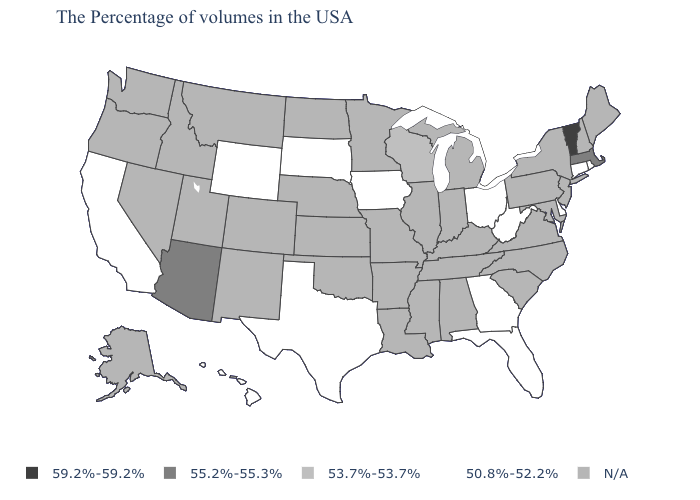What is the value of Texas?
Answer briefly. 50.8%-52.2%. Among the states that border Kentucky , which have the highest value?
Give a very brief answer. West Virginia, Ohio. What is the value of Massachusetts?
Be succinct. 55.2%-55.3%. Name the states that have a value in the range 55.2%-55.3%?
Answer briefly. Massachusetts, Arizona. Name the states that have a value in the range 50.8%-52.2%?
Answer briefly. Rhode Island, Connecticut, Delaware, West Virginia, Ohio, Florida, Georgia, Iowa, Texas, South Dakota, Wyoming, California, Hawaii. What is the value of Kansas?
Be succinct. N/A. What is the highest value in the West ?
Be succinct. 55.2%-55.3%. What is the lowest value in the USA?
Quick response, please. 50.8%-52.2%. What is the value of Delaware?
Write a very short answer. 50.8%-52.2%. Name the states that have a value in the range 59.2%-59.2%?
Give a very brief answer. Vermont. What is the lowest value in states that border Oklahoma?
Quick response, please. 50.8%-52.2%. Name the states that have a value in the range 59.2%-59.2%?
Be succinct. Vermont. 